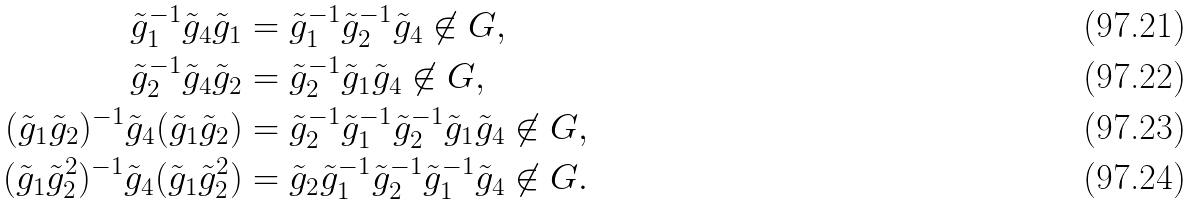Convert formula to latex. <formula><loc_0><loc_0><loc_500><loc_500>\tilde { g } _ { 1 } ^ { - 1 } \tilde { g } _ { 4 } \tilde { g } _ { 1 } & = \tilde { g } _ { 1 } ^ { - 1 } \tilde { g } ^ { - 1 } _ { 2 } \tilde { g } _ { 4 } \not \in G , \\ \tilde { g } _ { 2 } ^ { - 1 } \tilde { g } _ { 4 } \tilde { g } _ { 2 } & = \tilde { g } _ { 2 } ^ { - 1 } \tilde { g } _ { 1 } \tilde { g } _ { 4 } \not \in G , \\ ( \tilde { g } _ { 1 } \tilde { g } _ { 2 } ) ^ { - 1 } \tilde { g } _ { 4 } ( \tilde { g } _ { 1 } \tilde { g } _ { 2 } ) & = \tilde { g } _ { 2 } ^ { - 1 } \tilde { g } ^ { - 1 } _ { 1 } \tilde { g } ^ { - 1 } _ { 2 } \tilde { g } _ { 1 } \tilde { g } _ { 4 } \not \in G , \\ ( \tilde { g } _ { 1 } \tilde { g } ^ { 2 } _ { 2 } ) ^ { - 1 } \tilde { g } _ { 4 } ( \tilde { g } _ { 1 } \tilde { g } ^ { 2 } _ { 2 } ) & = \tilde { g } _ { 2 } \tilde { g } ^ { - 1 } _ { 1 } \tilde { g } ^ { - 1 } _ { 2 } \tilde { g } ^ { - 1 } _ { 1 } \tilde { g } _ { 4 } \not \in G .</formula> 